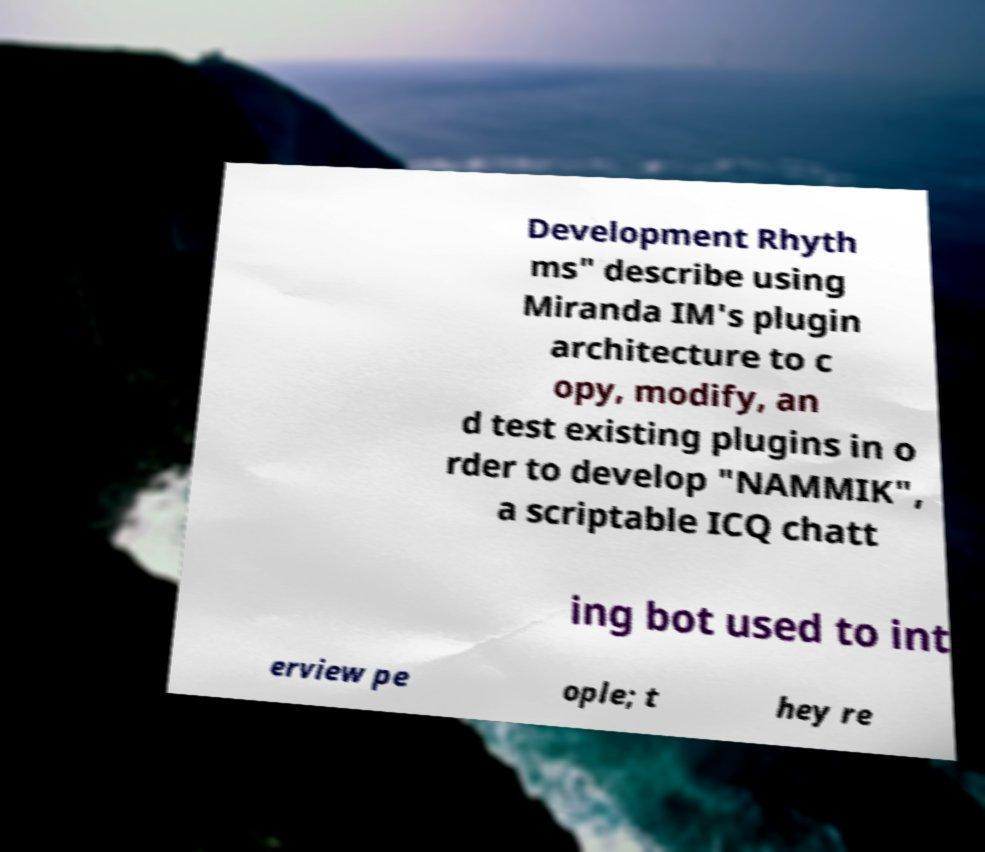Please read and relay the text visible in this image. What does it say? Development Rhyth ms" describe using Miranda IM's plugin architecture to c opy, modify, an d test existing plugins in o rder to develop "NAMMIK", a scriptable ICQ chatt ing bot used to int erview pe ople; t hey re 